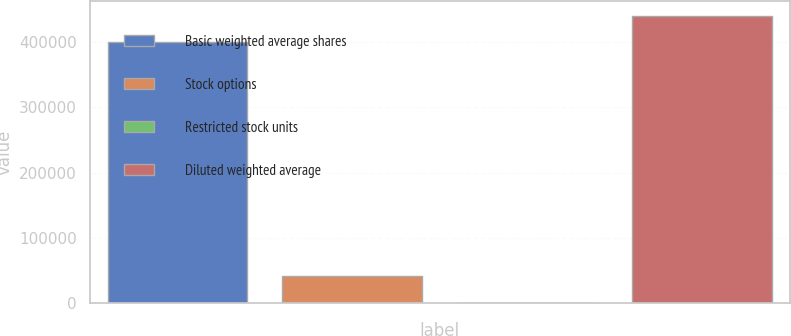Convert chart. <chart><loc_0><loc_0><loc_500><loc_500><bar_chart><fcel>Basic weighted average shares<fcel>Stock options<fcel>Restricted stock units<fcel>Diluted weighted average<nl><fcel>399891<fcel>41274<fcel>1009<fcel>440156<nl></chart> 